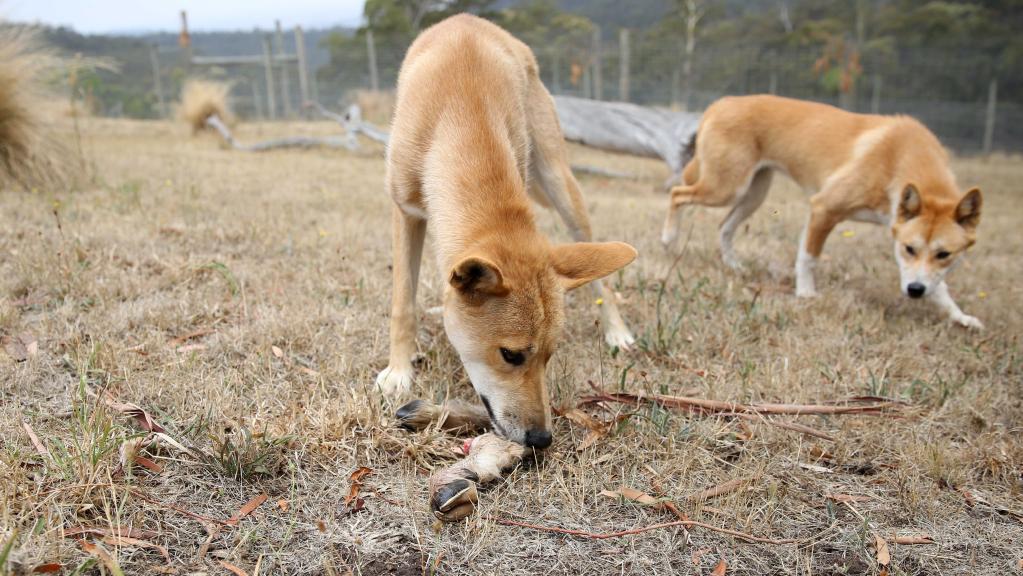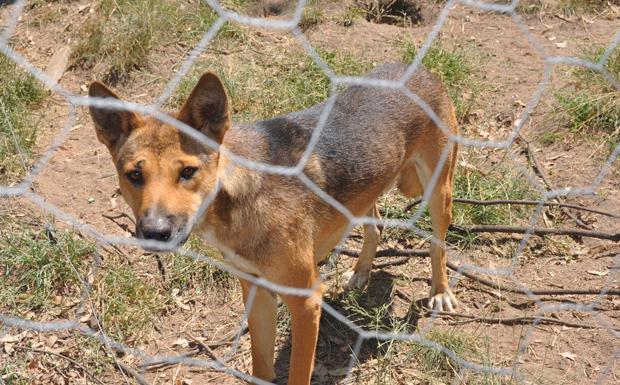The first image is the image on the left, the second image is the image on the right. Analyze the images presented: Is the assertion "The left image contains one standing dingo and a fallen log, and the right image contains exactly two standing dingos." valid? Answer yes or no. No. The first image is the image on the left, the second image is the image on the right. For the images displayed, is the sentence "One of the images contains a single dog in a wooded area." factually correct? Answer yes or no. No. 